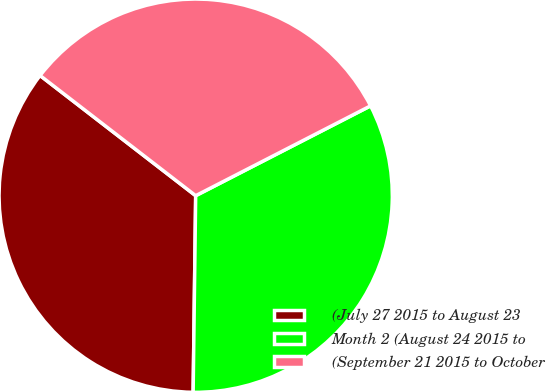<chart> <loc_0><loc_0><loc_500><loc_500><pie_chart><fcel>(July 27 2015 to August 23<fcel>Month 2 (August 24 2015 to<fcel>(September 21 2015 to October<nl><fcel>35.26%<fcel>32.76%<fcel>31.98%<nl></chart> 